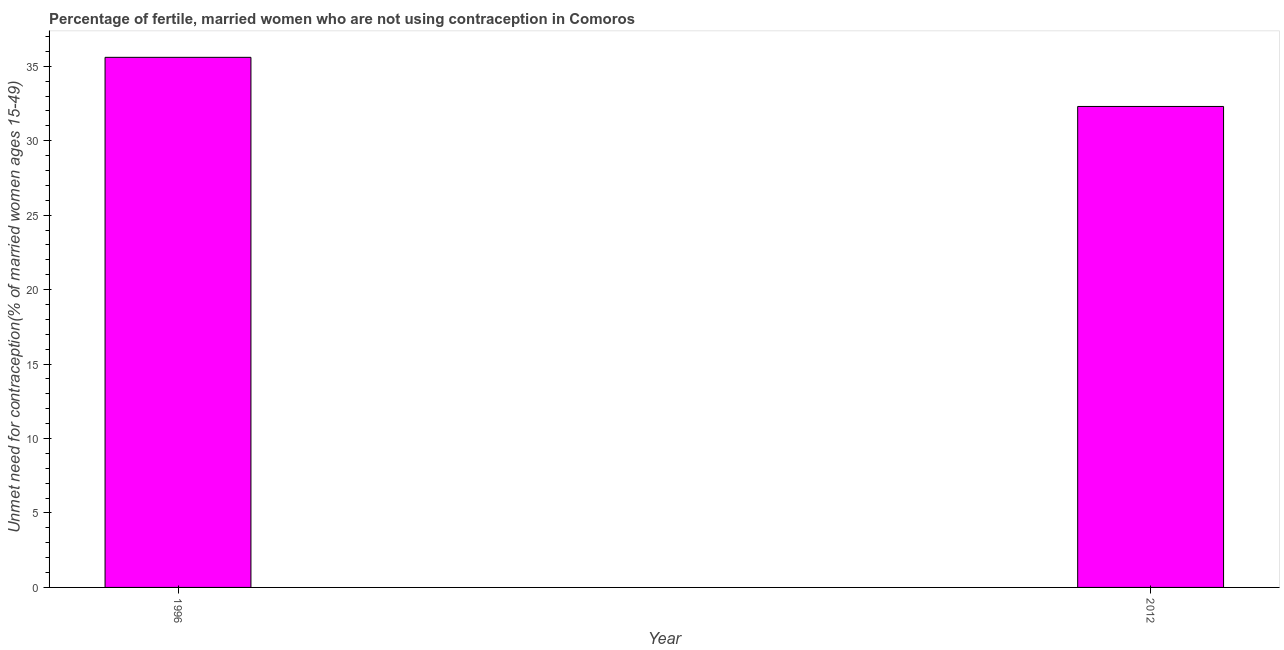Does the graph contain grids?
Offer a terse response. No. What is the title of the graph?
Your response must be concise. Percentage of fertile, married women who are not using contraception in Comoros. What is the label or title of the Y-axis?
Offer a very short reply.  Unmet need for contraception(% of married women ages 15-49). What is the number of married women who are not using contraception in 2012?
Provide a short and direct response. 32.3. Across all years, what is the maximum number of married women who are not using contraception?
Offer a very short reply. 35.6. Across all years, what is the minimum number of married women who are not using contraception?
Offer a terse response. 32.3. In which year was the number of married women who are not using contraception minimum?
Keep it short and to the point. 2012. What is the sum of the number of married women who are not using contraception?
Make the answer very short. 67.9. What is the average number of married women who are not using contraception per year?
Offer a terse response. 33.95. What is the median number of married women who are not using contraception?
Your response must be concise. 33.95. Do a majority of the years between 1996 and 2012 (inclusive) have number of married women who are not using contraception greater than 12 %?
Provide a short and direct response. Yes. What is the ratio of the number of married women who are not using contraception in 1996 to that in 2012?
Provide a succinct answer. 1.1. Is the number of married women who are not using contraception in 1996 less than that in 2012?
Offer a terse response. No. In how many years, is the number of married women who are not using contraception greater than the average number of married women who are not using contraception taken over all years?
Offer a terse response. 1. How many bars are there?
Your answer should be very brief. 2. Are all the bars in the graph horizontal?
Your answer should be compact. No. What is the  Unmet need for contraception(% of married women ages 15-49) in 1996?
Give a very brief answer. 35.6. What is the  Unmet need for contraception(% of married women ages 15-49) of 2012?
Your answer should be very brief. 32.3. What is the difference between the  Unmet need for contraception(% of married women ages 15-49) in 1996 and 2012?
Offer a very short reply. 3.3. What is the ratio of the  Unmet need for contraception(% of married women ages 15-49) in 1996 to that in 2012?
Your answer should be very brief. 1.1. 